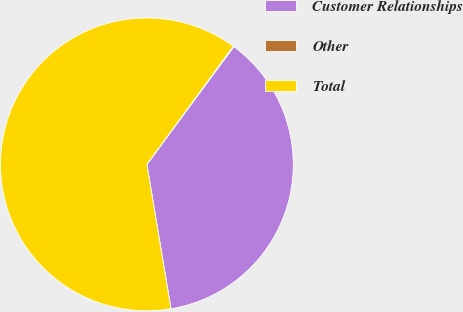<chart> <loc_0><loc_0><loc_500><loc_500><pie_chart><fcel>Customer Relationships<fcel>Other<fcel>Total<nl><fcel>37.24%<fcel>0.08%<fcel>62.68%<nl></chart> 